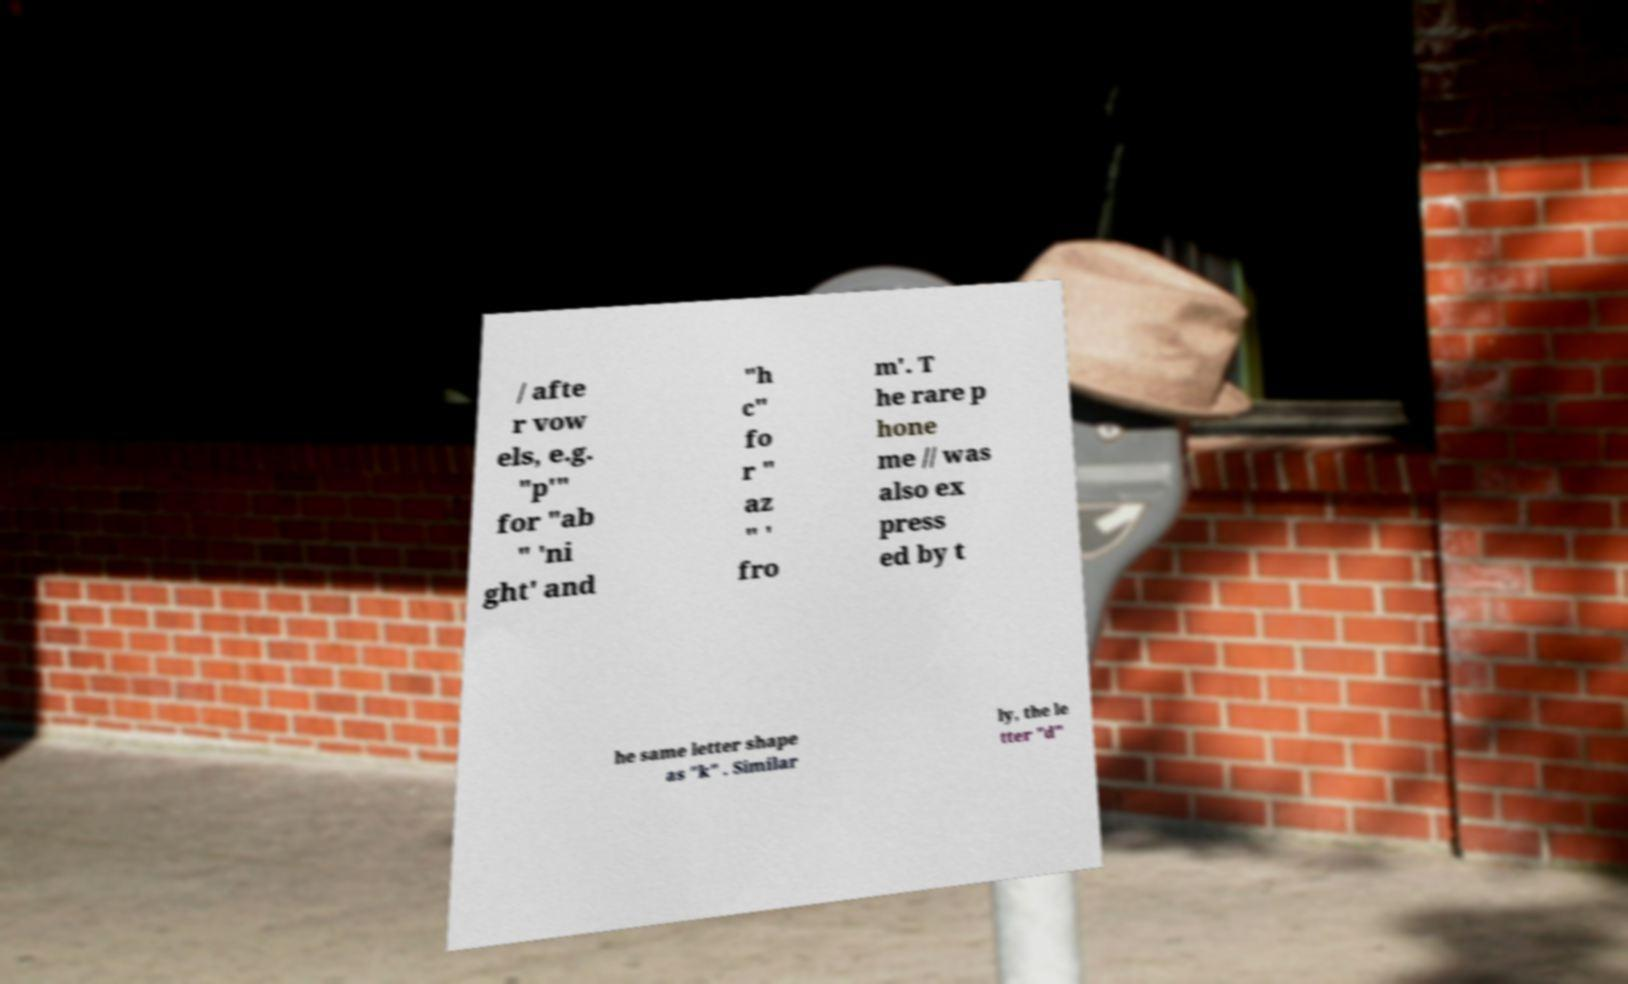There's text embedded in this image that I need extracted. Can you transcribe it verbatim? / afte r vow els, e.g. "p'" for "ab " 'ni ght' and "h c" fo r " az " ' fro m'. T he rare p hone me // was also ex press ed by t he same letter shape as "k" . Similar ly, the le tter "d" 